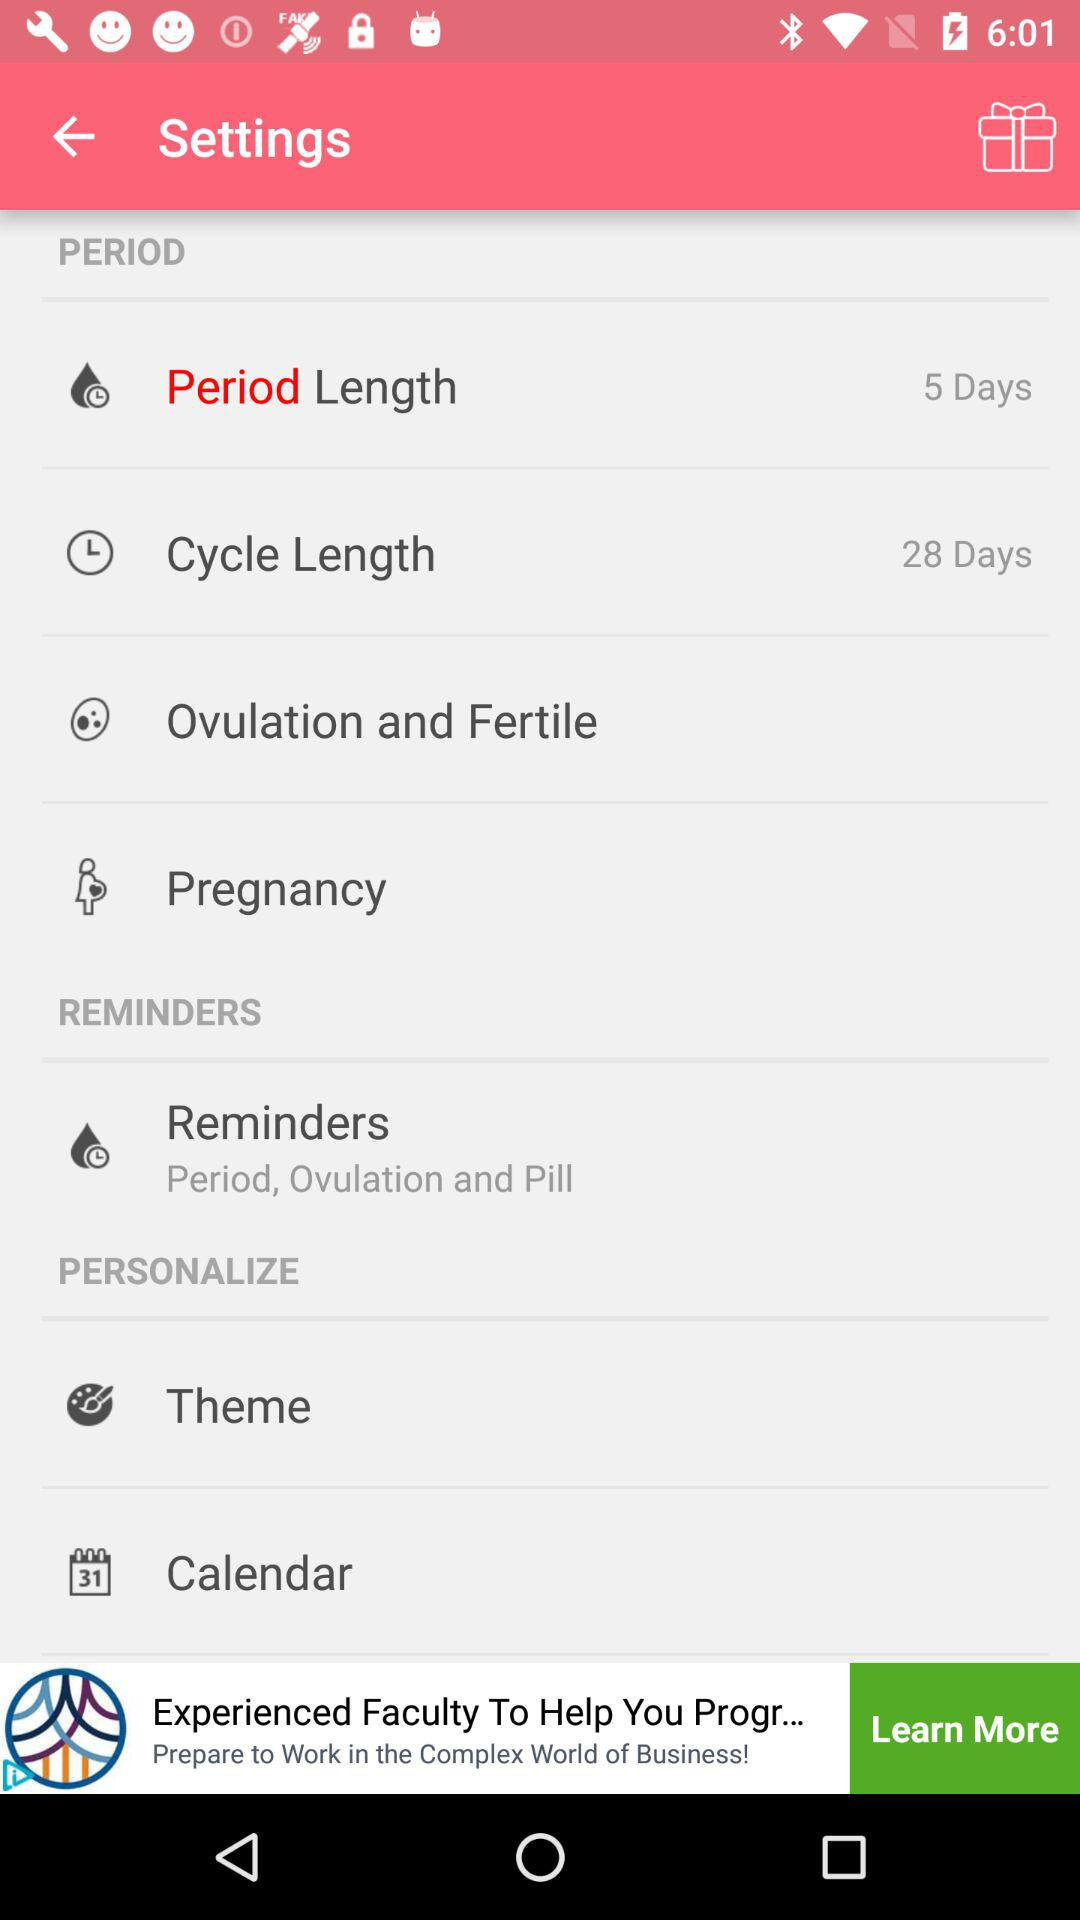What is the cycle length? The cycle length is 28 days. 